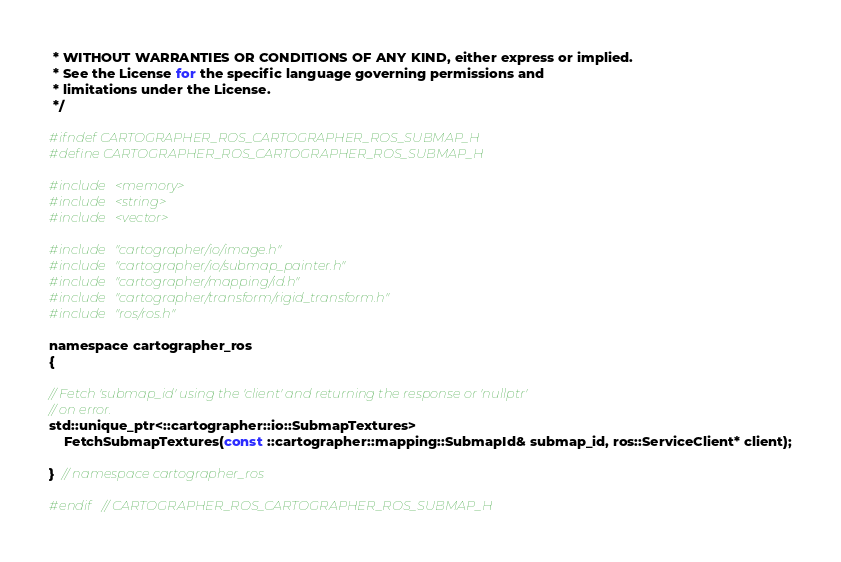Convert code to text. <code><loc_0><loc_0><loc_500><loc_500><_C_> * WITHOUT WARRANTIES OR CONDITIONS OF ANY KIND, either express or implied.
 * See the License for the specific language governing permissions and
 * limitations under the License.
 */

#ifndef CARTOGRAPHER_ROS_CARTOGRAPHER_ROS_SUBMAP_H
#define CARTOGRAPHER_ROS_CARTOGRAPHER_ROS_SUBMAP_H

#include <memory>
#include <string>
#include <vector>

#include "cartographer/io/image.h"
#include "cartographer/io/submap_painter.h"
#include "cartographer/mapping/id.h"
#include "cartographer/transform/rigid_transform.h"
#include "ros/ros.h"

namespace cartographer_ros
{

// Fetch 'submap_id' using the 'client' and returning the response or 'nullptr'
// on error.
std::unique_ptr<::cartographer::io::SubmapTextures>
    FetchSubmapTextures(const ::cartographer::mapping::SubmapId& submap_id, ros::ServiceClient* client);

}  // namespace cartographer_ros

#endif  // CARTOGRAPHER_ROS_CARTOGRAPHER_ROS_SUBMAP_H
</code> 